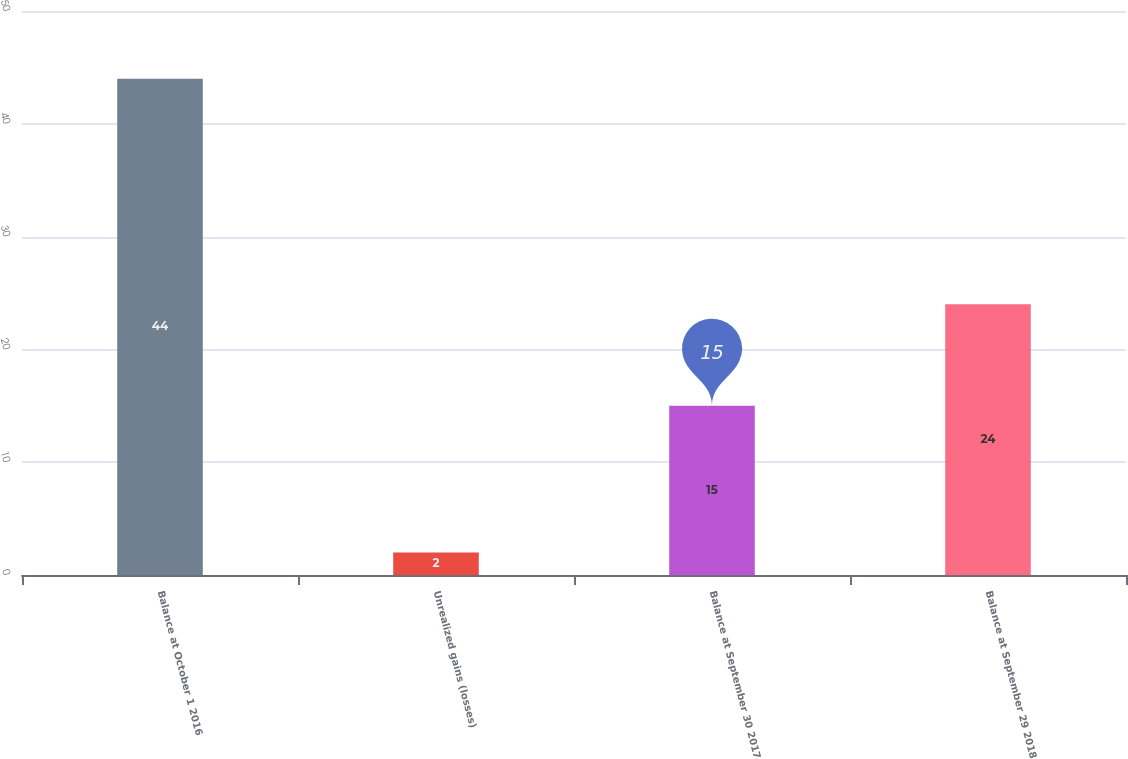Convert chart. <chart><loc_0><loc_0><loc_500><loc_500><bar_chart><fcel>Balance at October 1 2016<fcel>Unrealized gains (losses)<fcel>Balance at September 30 2017<fcel>Balance at September 29 2018<nl><fcel>44<fcel>2<fcel>15<fcel>24<nl></chart> 